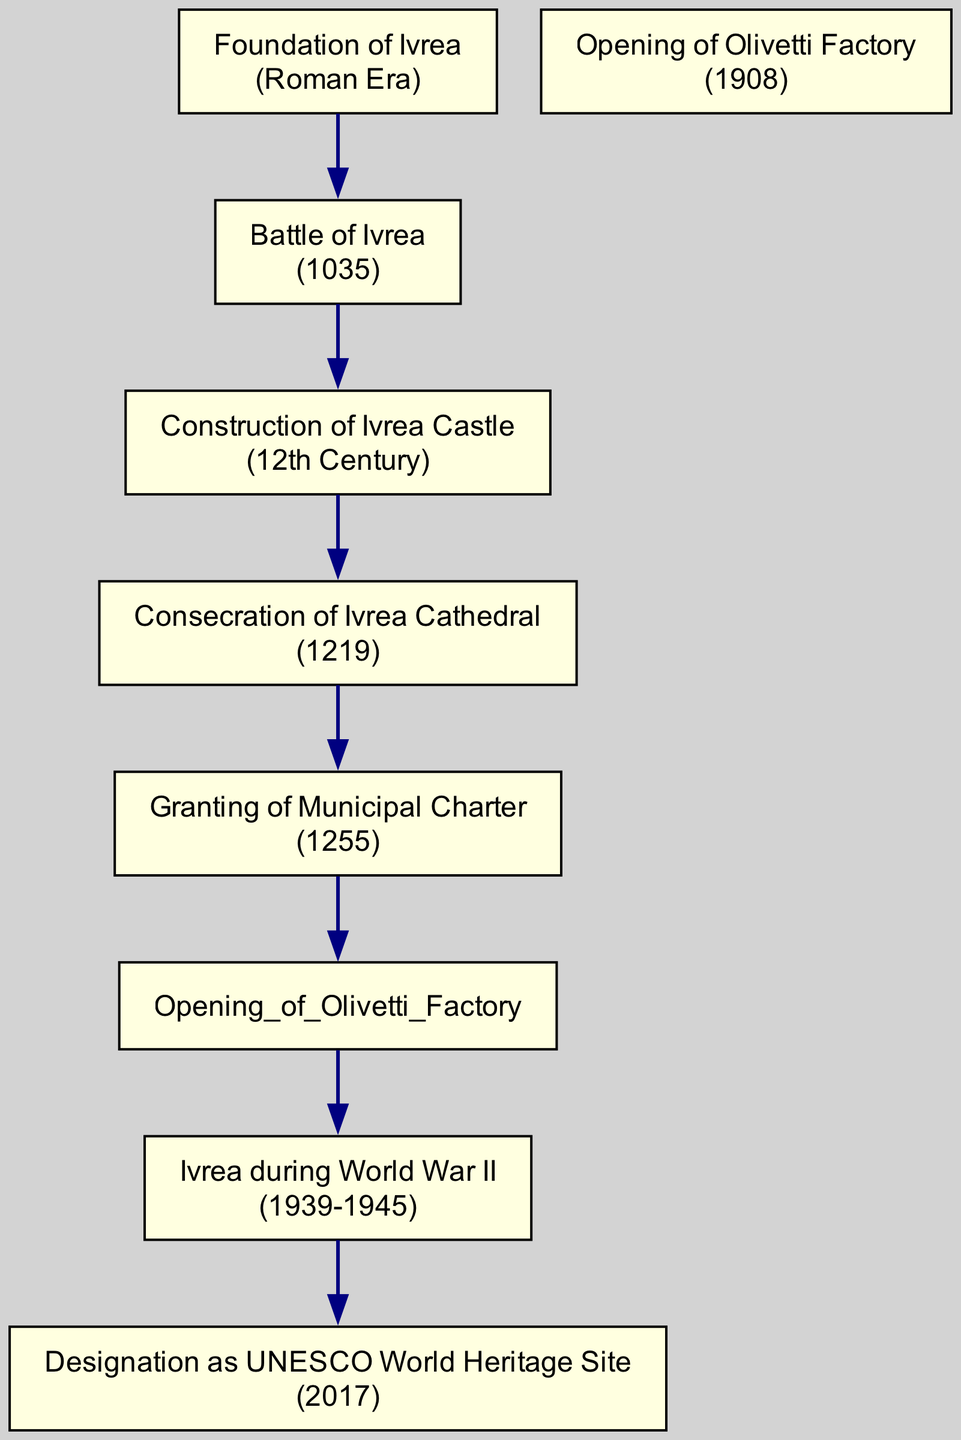What is the earliest historical event in Ivrea? The diagram begins with the "Foundation of Ivrea," which is labeled as occurring during the Roman Era. This is the first event listed in the timeline.
Answer: Foundation of Ivrea What year did the Battle of Ivrea take place? The node for "Battle of Ivrea" specifies the year 1035. This is a direct reference from the diagram to the event's associated year.
Answer: 1035 Which event comes after the Consecration of Ivrea Cathedral? Following the "Consecration of Ivrea Cathedral," the next edge leads to the "Granting of Municipal Charter." This connection indicates the sequence of events in the timeline.
Answer: Granting of Municipal Charter How many historical events are represented in the diagram? The total number of nodes in the diagram represents distinct historical events. In this case, there are 7 nodes listed, each representing one event.
Answer: 7 What was the last event in the timeline of Ivrea? The last event in the directed graph is "Designation as UNESCO World Heritage Site," which follows "Ivrea during World War II." This is the final node listed.
Answer: Designation as UNESCO World Heritage Site Which event directly precedes the opening of the Olivetti Factory? According to the directed edges in the diagram, the event directly before "Opening of Olivetti Factory" is the "Granting of Municipal Charter." This is the preceding connection in the flow.
Answer: Granting of Municipal Charter What is the relationship between Ivrea in World War II and UNESCO designation? The directed graph shows that "Ivrea during World War II" points to "Designation as UNESCO World Heritage Site." This means that the period of World War II is connected to the later UNESCO designation in terms of historical timeline.
Answer: ivrea during World War II points to designation as UNESCO World Heritage Site In which century was the Ivrea Castle constructed? The diagram specifies that the "Construction of Ivrea Castle" occurred in the 12th Century. This information is explicitly stated in the timeline.
Answer: 12th Century What historical event is directly linked to the foundation of Ivrea? The node "Battle of Ivrea" is directly connected to "Foundation of Ivrea," as indicated by an edge in the diagram. This suggests a chronological link between the two historical events.
Answer: Battle of Ivrea 